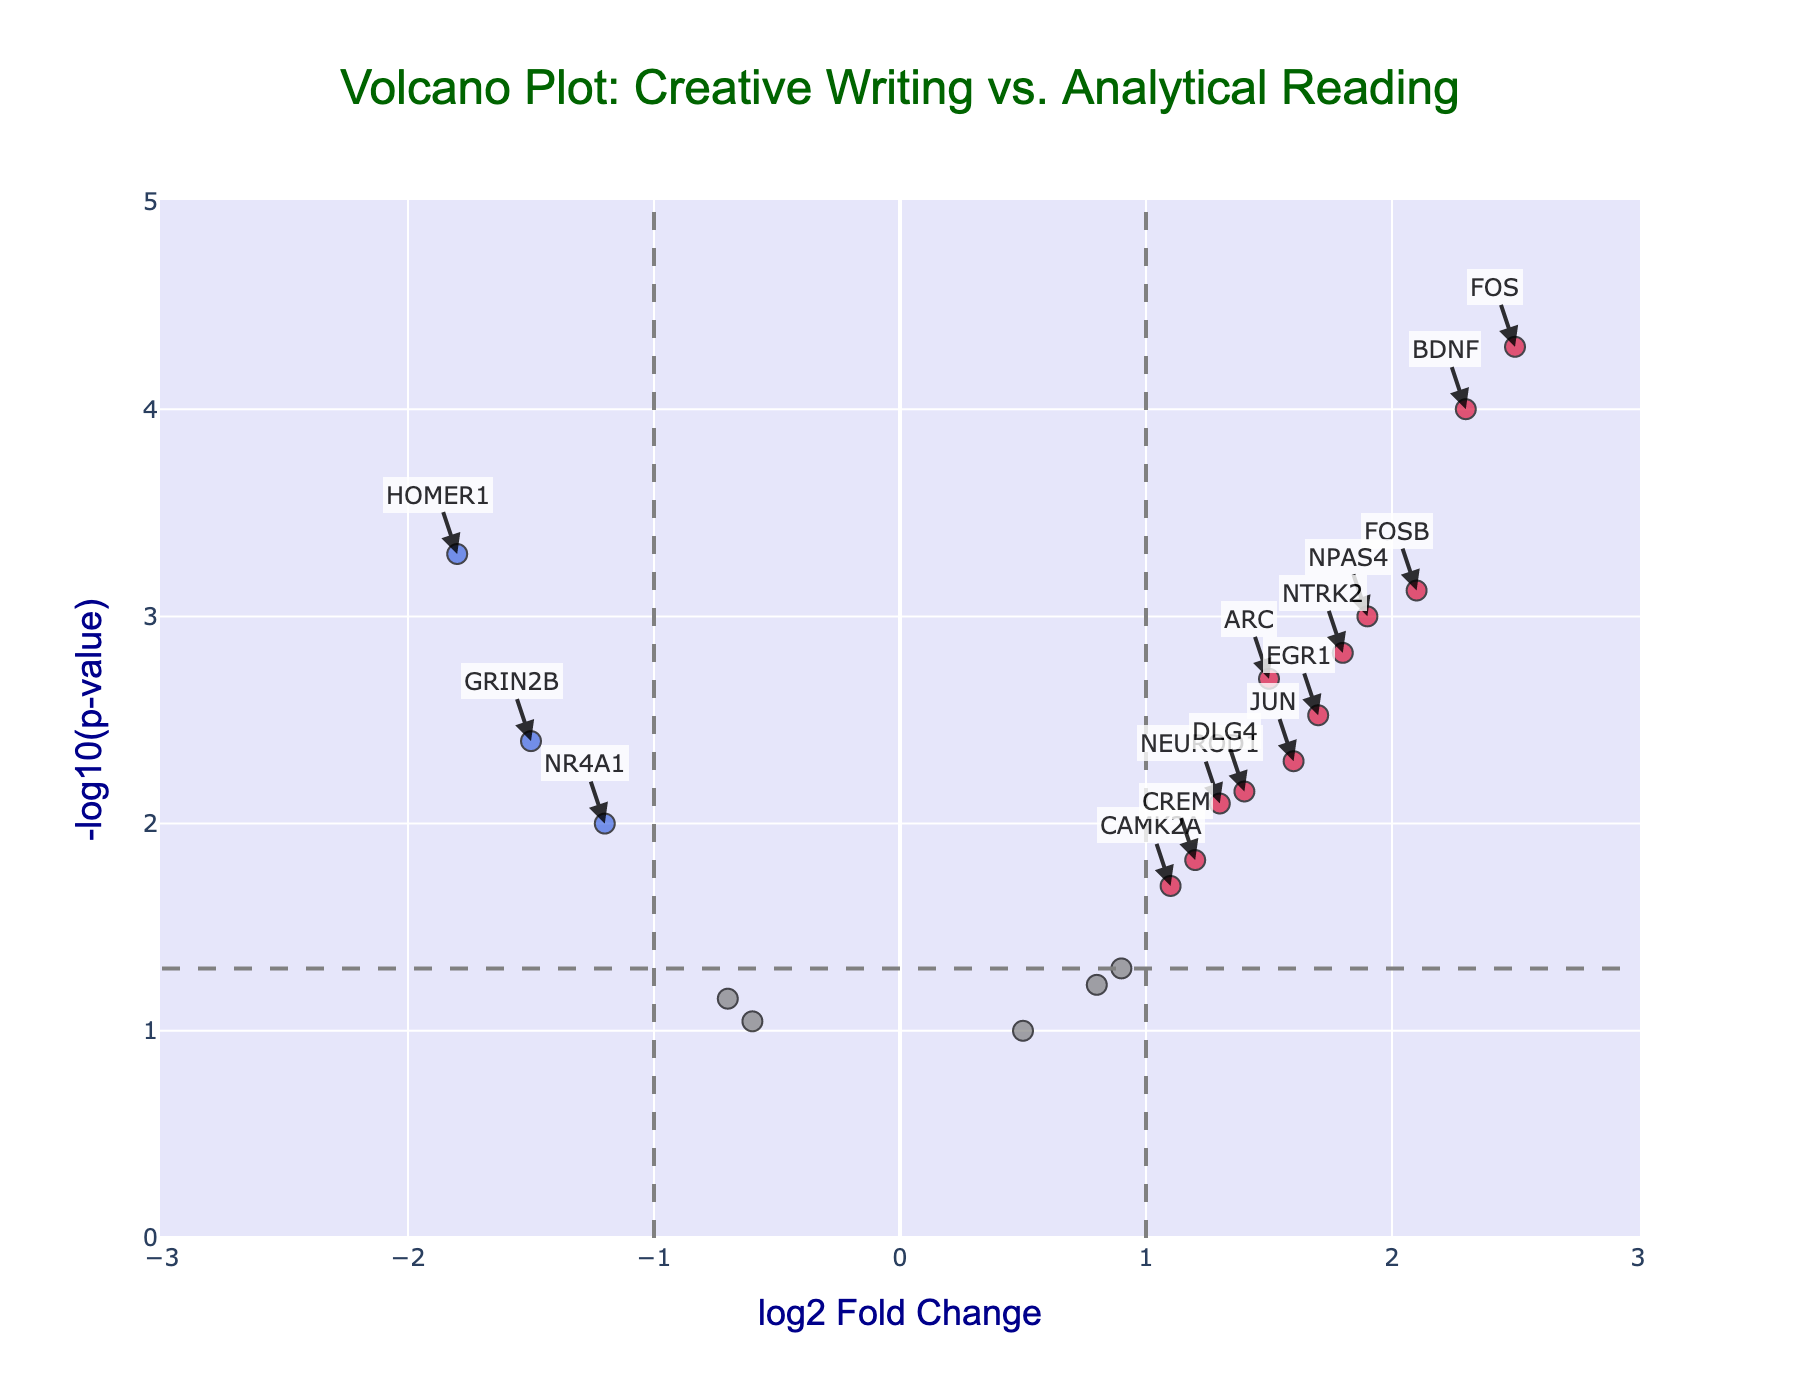What is the title of the plot? The title of the plot is located at the top center and usually provides a summary of what the plot depicts. Here, it reads "Volcano Plot: Creative Writing vs. Analytical Reading".
Answer: Volcano Plot: Creative Writing vs. Analytical Reading What are the x-axis and y-axis labels? The x-axis and y-axis labels are positioned along the horizontal and vertical axes respectively. In this plot, the x-axis label is "log2 Fold Change" and the y-axis label is "-log10(p-value)".
Answer: log2 Fold Change; -log10(p-value) How many data points are displayed on the plot? Each marker on the plot represents one data point. Since there are 20 genes in the dataset and each gene is plotted as a marker, the plot displays 20 data points.
Answer: 20 What do the crimson and royal blue colors represent on the plot? These colors highlight significant genes based on thresholds for fold change and p-value. Crimson indicates genes with log2FoldChange > 1 and p-value < 0.05, while royal blue indicates genes with log2FoldChange < -1 and p-value < 0.05.
Answer: Significant genes How many genes are significantly upregulated in creative writing compared to analytical reading? Look at the number of crimson dots, as they represent significant upregulation (log2FoldChange > 1 and p-value < 0.05). There are 6 genes colored crimson.
Answer: 6 How many genes are significantly downregulated in creative writing compared to analytical reading? Count the number of royal blue dots, representing significant downregulation (log2FoldChange < -1 and p-value < 0.05). There are 2 genes colored royal blue.
Answer: 2 Which gene is the most significantly upregulated, and what are its values? The gene in crimson with the highest -log10(p-value) is most significantly upregulated. Here, FOS is the highest at (log2FoldChange = 2.5, -log10(pvalue) = 4.301), meaning the lowest p-value.
Answer: FOS; log2FoldChange = 2.5; -log10(pvalue) = 4.301 Which gene is the most significantly downregulated, and what are its values? The gene in royal blue with the highest -log10(p-value) is most significantly downregulated. It is HOMER1 with (log2FoldChange = -1.8, -log10(pvalue) = 3.301).
Answer: HOMER1; log2FoldChange = -1.8; -log10(pvalue) = 3.301 What is the log2FoldChange value for NR4A1? Is it considered significant? Locate the data point for NR4A1 on the plot, shown in grey. NR4A1 has log2FoldChange = -1.2 and p-value < 0.05. Although it meets the p-value threshold, its log2FoldChange does not exceed ±1, so it is not highlighted as significant.
Answer: -1.2; No How does CREB1 compare to CREM in terms of significance and fold change? CREB1 is grey (log2FoldChange = 0.9; p-value = 0.05) and not significant, while CREM is grey (log2FoldChange = 1.2; p-value = 0.015), which is significant due to p-value yet not highlighted as it's not exceeding log2FoldChange threshold.
Answer: CREB1 is not significant; CREM is significant 